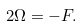Convert formula to latex. <formula><loc_0><loc_0><loc_500><loc_500>2 \Omega = - F .</formula> 